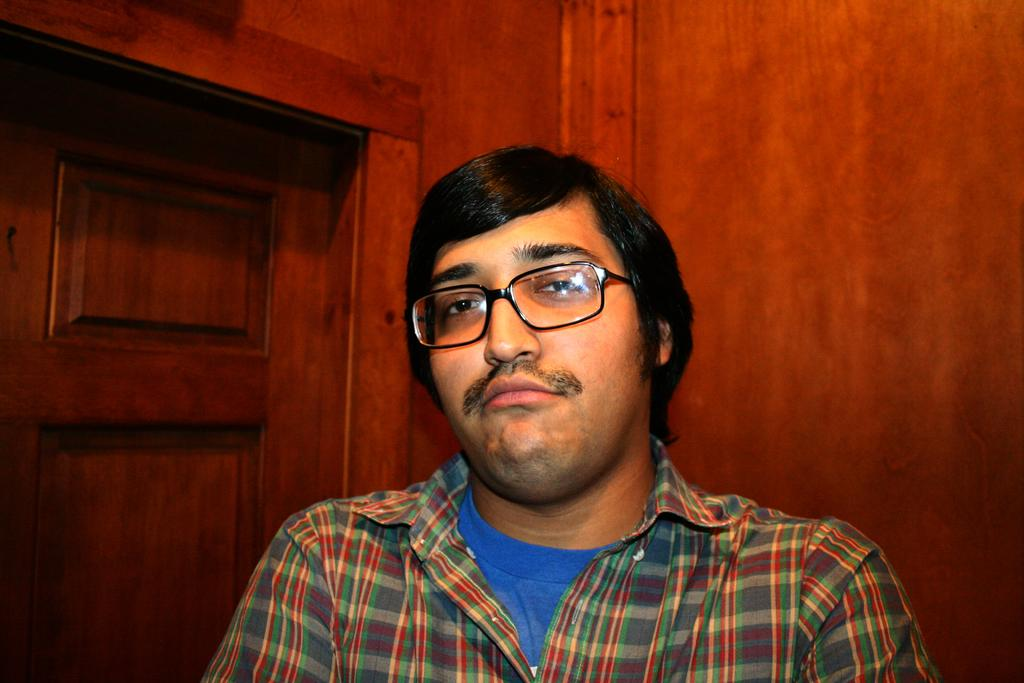Who or what is present in the image? There is a person in the image. What can be observed about the person's appearance? The person is wearing spectacles. What architectural feature is visible on the left side of the image? There is a door visible on the left side of the image. What material seems to dominate the background of the image? The background of the image appears to be wooden. What type of riddle is the person trying to solve in the image? There is no indication in the image that the person is trying to solve a riddle. How does the person's throat look in the image? The image does not show the person's throat, so it cannot be described. 